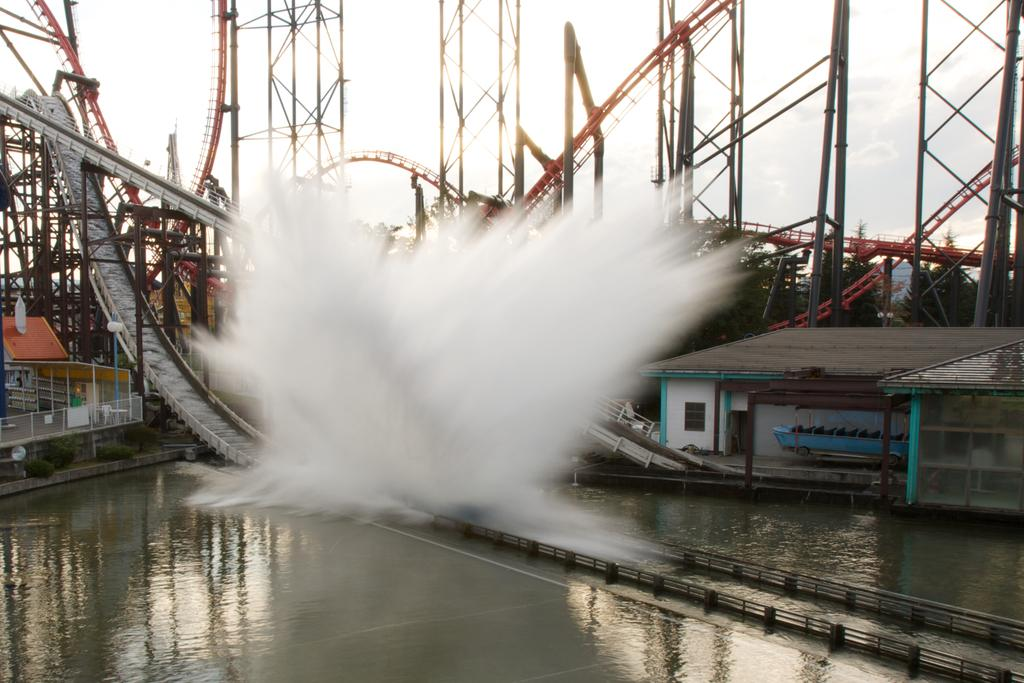Where was the image taken? The image was taken in an amusement park. What can be seen in the foreground of the image? There is a water body in the foreground of the image. What type of structures are present in the middle of the image? There are iron constructions in the middle of the image. What is visible in the background of the image? The sky is visible in the background of the image. What type of fiction is being read by the people in the image? There are no people reading fiction in the image; it is taken in an amusement park with a water body, iron constructions, and a visible sky. 